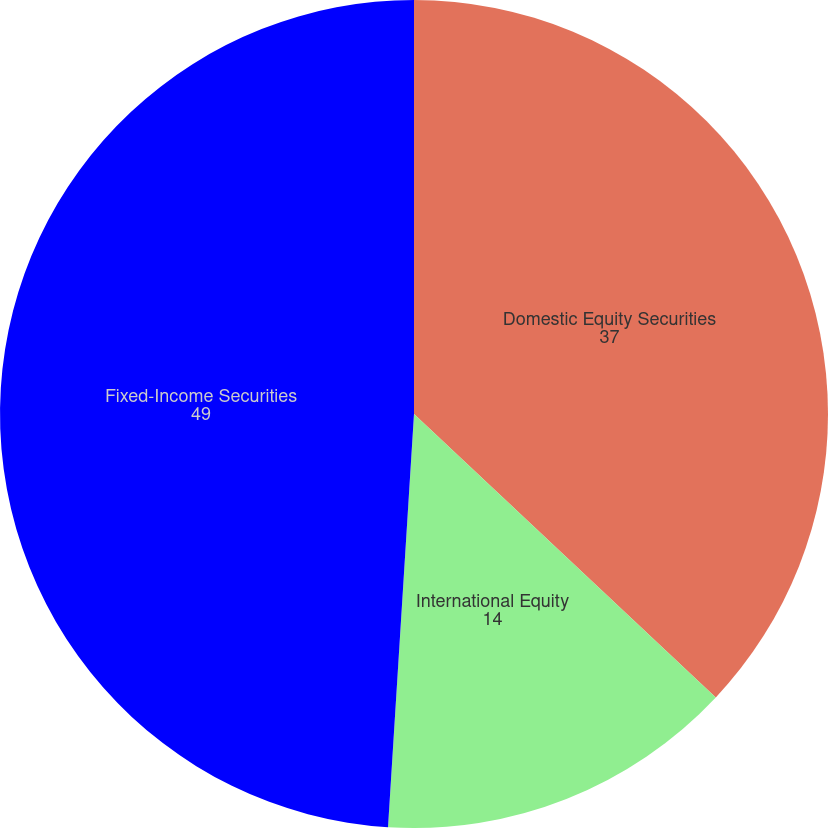Convert chart to OTSL. <chart><loc_0><loc_0><loc_500><loc_500><pie_chart><fcel>Domestic Equity Securities<fcel>International Equity<fcel>Fixed-Income Securities<nl><fcel>37.0%<fcel>14.0%<fcel>49.0%<nl></chart> 